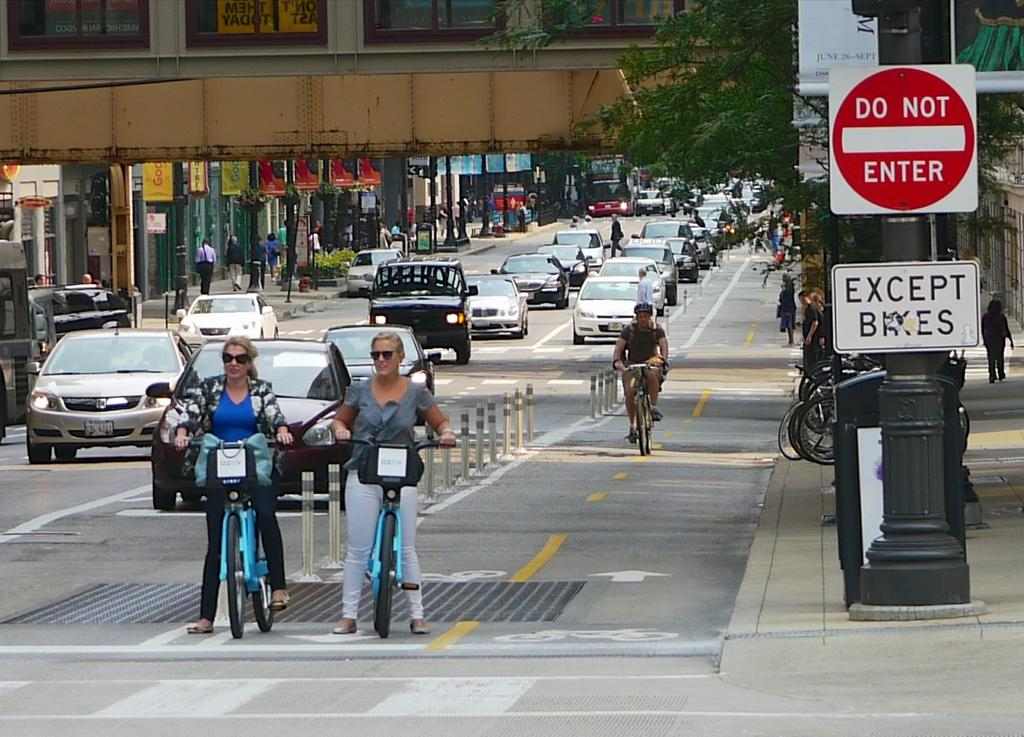What can be seen on the road in the image? There are vehicles on the road in the image. Who or what else can be seen in the image? There are people visible in the image. What is located on the right side of the image? There are boards with text on the right side of the image. What type of corn is being harvested in the image? There is no corn present in the image; it features vehicles on the road, people, and boards with text. Can you tell me how many fish are swimming in the water in the image? There is no water or fish present in the image. 